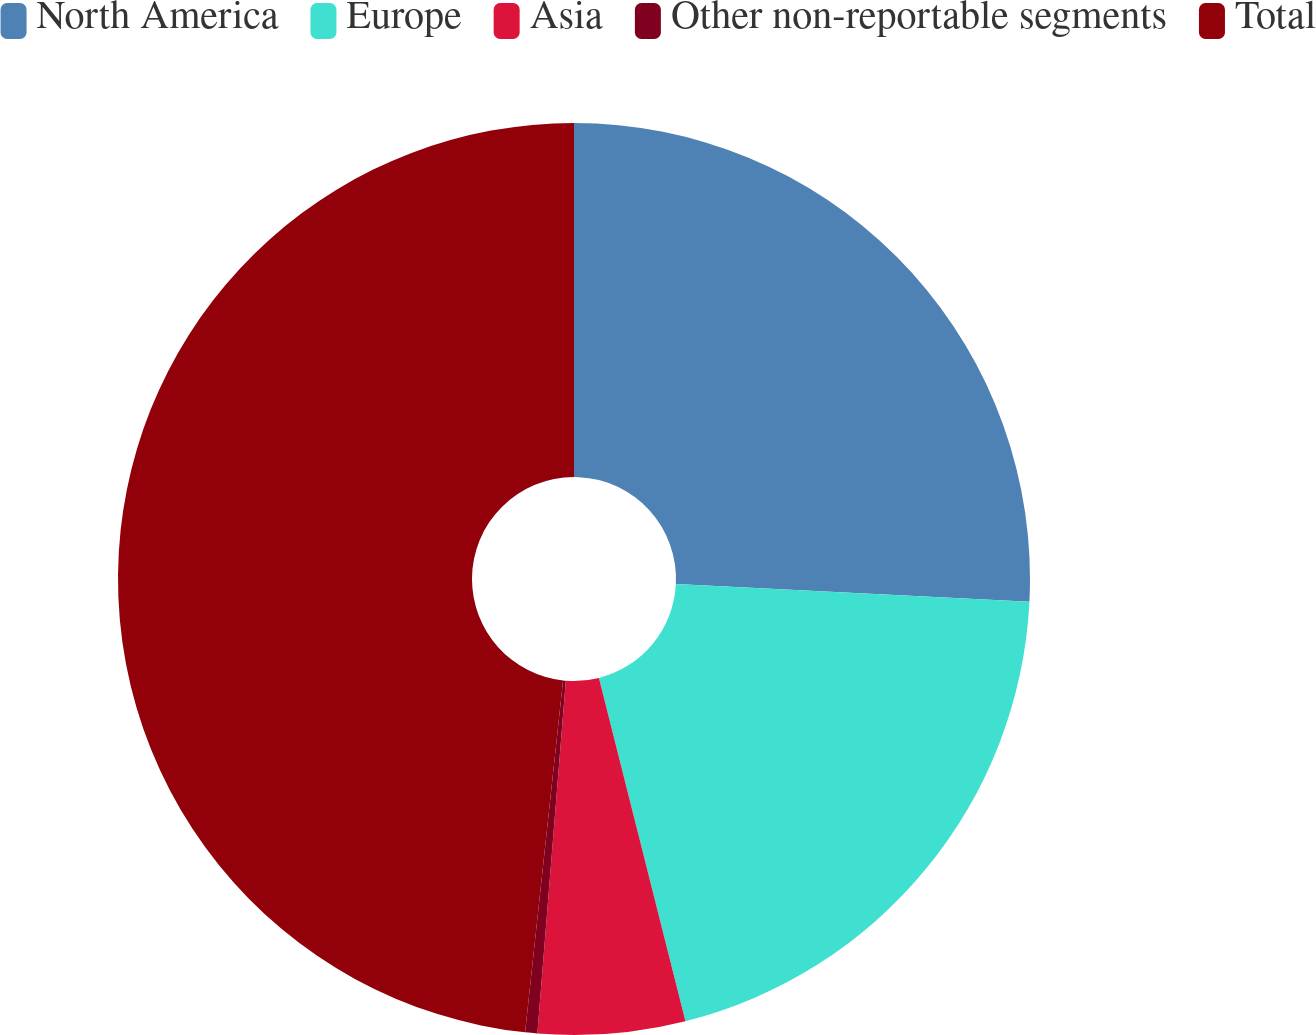Convert chart to OTSL. <chart><loc_0><loc_0><loc_500><loc_500><pie_chart><fcel>North America<fcel>Europe<fcel>Asia<fcel>Other non-reportable segments<fcel>Total<nl><fcel>25.79%<fcel>20.28%<fcel>5.21%<fcel>0.43%<fcel>48.29%<nl></chart> 